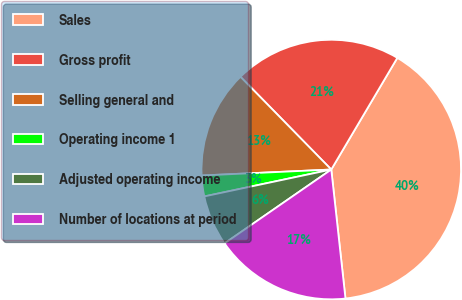Convert chart. <chart><loc_0><loc_0><loc_500><loc_500><pie_chart><fcel>Sales<fcel>Gross profit<fcel>Selling general and<fcel>Operating income 1<fcel>Adjusted operating income<fcel>Number of locations at period<nl><fcel>39.75%<fcel>20.83%<fcel>13.4%<fcel>2.59%<fcel>6.31%<fcel>17.11%<nl></chart> 